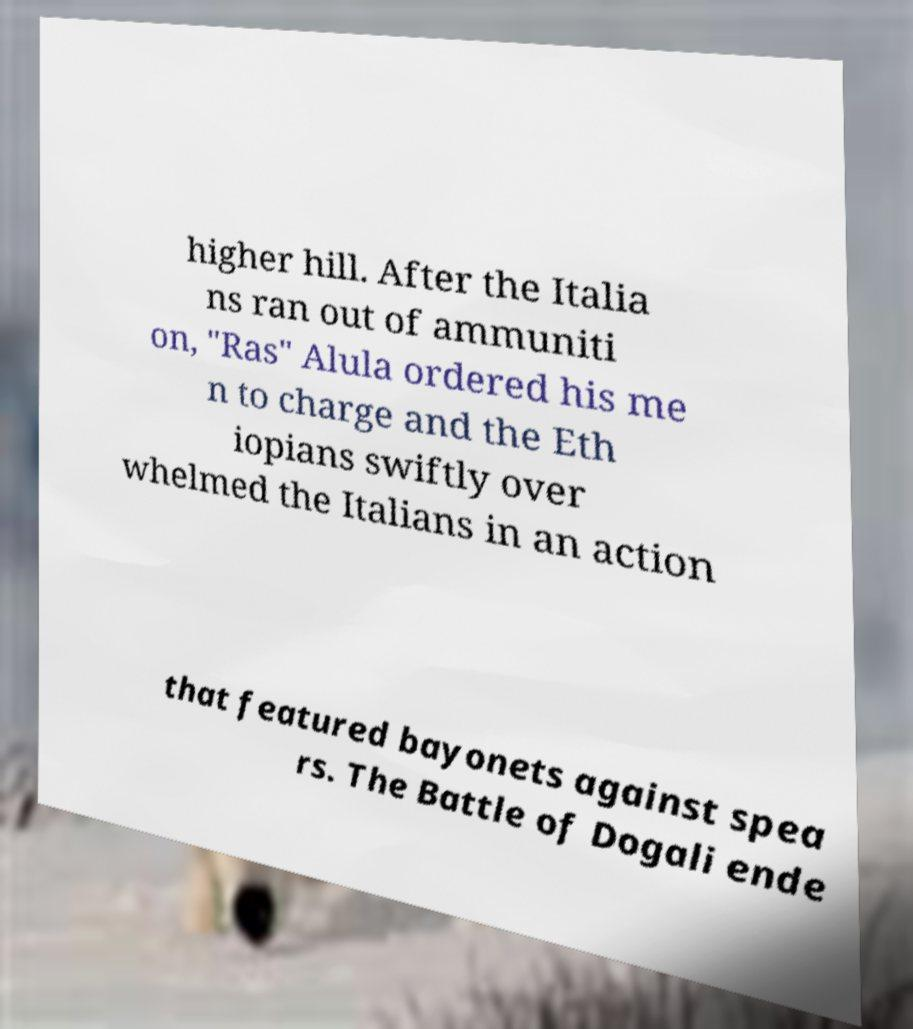I need the written content from this picture converted into text. Can you do that? higher hill. After the Italia ns ran out of ammuniti on, "Ras" Alula ordered his me n to charge and the Eth iopians swiftly over whelmed the Italians in an action that featured bayonets against spea rs. The Battle of Dogali ende 